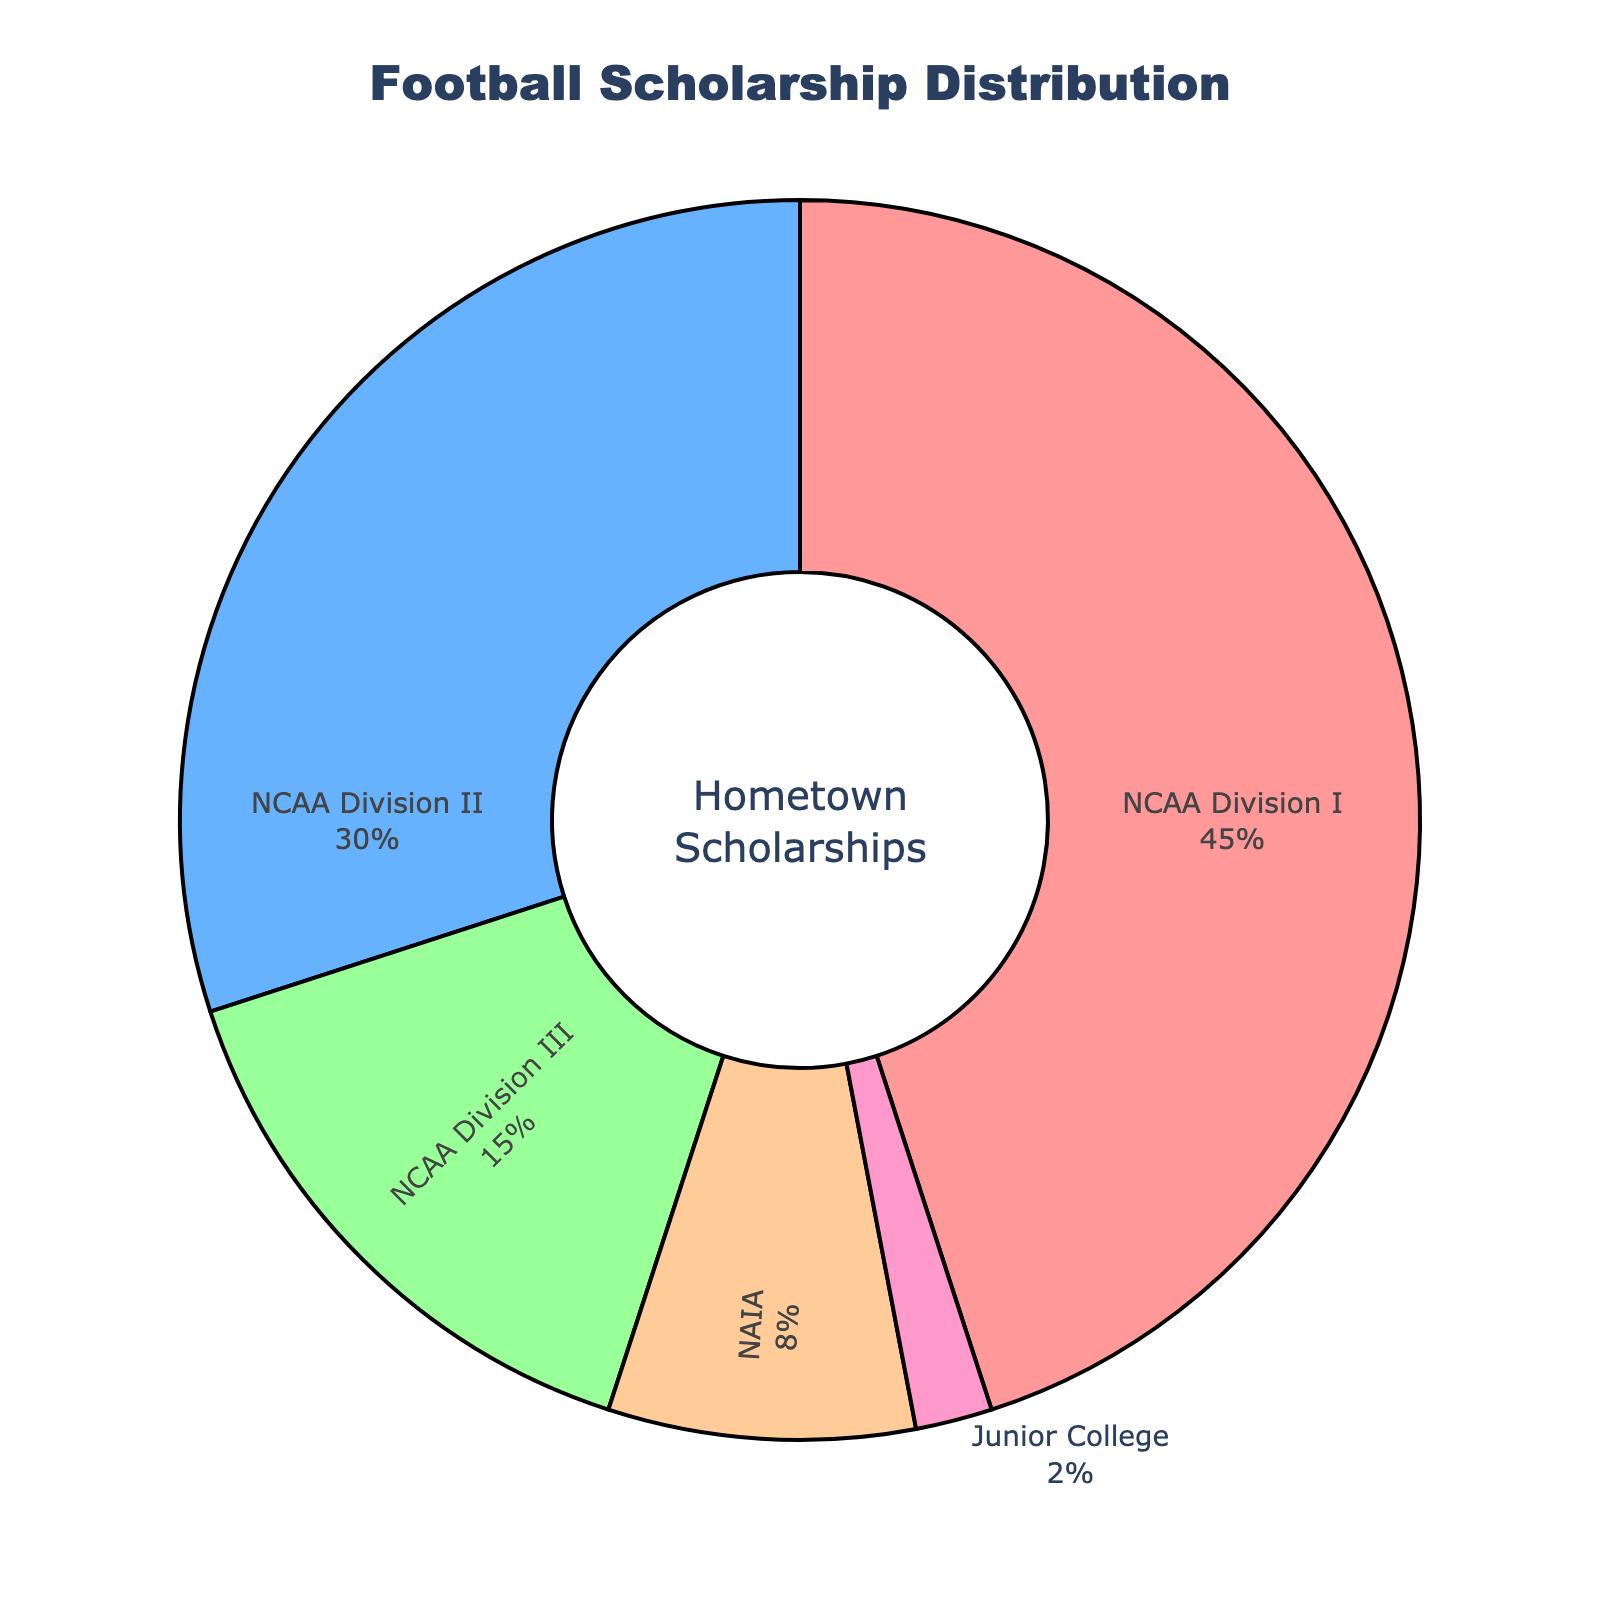What percentage of scholarships go to athletes in NCAA Division II and NCAA Division III combined? Add the percentages of NCAA Division II and NCAA Division III: 30% + 15% = 45%
Answer: 45% Which division awards the highest percentage of football scholarships? The division with the highest percentage is NCAA Division I with 45% as indicated by the largest segment of the pie chart.
Answer: NCAA Division I How much more percentage of scholarships does NAIA award compared to Junior College? Subtract the percentage of Junior College from the percentage of NAIA: 8% - 2% = 6%
Answer: 6% Is the percentage of scholarships awarded by NCAA Division I greater than the sum of NAIA and Junior College? Calculate the sum of NAIA and Junior College: 8% + 2% = 10%. Compare this with NCAA Division I's 45%. 45% is greater than 10%.
Answer: Yes What is the sum of the percentage of scholarships awarded to athletes by NAIA, Junior College, and NCAA Division III? Add the percentages of NAIA, Junior College, and NCAA Division III: 8% + 2% + 15% = 25%
Answer: 25% Which division awards the least percentage of scholarships? The division with the smallest percentage is Junior College with 2% as indicated by the smallest segment of the pie chart.
Answer: Junior College What percentage of total scholarships do NCAA divisions (I, II, III) account for together? Add the percentages of NCAA Division I, II, and III: 45% + 30% + 15% = 90%
Answer: 90% 